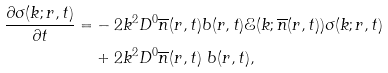Convert formula to latex. <formula><loc_0><loc_0><loc_500><loc_500>\frac { \partial \sigma ( k ; r , t ) } { \partial t } = & - 2 k ^ { 2 } D ^ { 0 } \overline { n } ( r , t ) b ( r , t ) \mathcal { E } ( k ; \overline { n } ( r , t ) ) \sigma ( k ; r , t ) \\ & + 2 k ^ { 2 } D ^ { 0 } \overline { n } ( r , t ) \ b ( r , t ) ,</formula> 